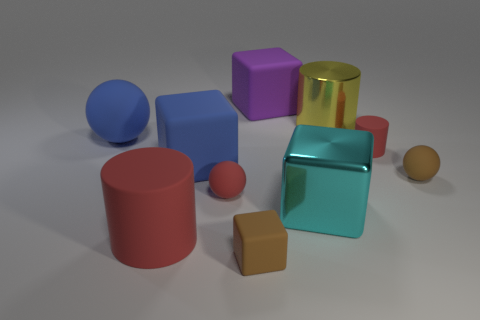What number of large blue rubber balls are left of the large cylinder on the left side of the small brown cube that is in front of the big metallic block?
Your answer should be compact. 1. Is the number of large blue matte cubes that are left of the large cyan object greater than the number of big cyan shiny blocks to the left of the yellow thing?
Provide a succinct answer. No. What number of things are either things on the left side of the tiny cylinder or cubes that are in front of the large yellow cylinder?
Keep it short and to the point. 8. What is the material of the block in front of the cylinder in front of the big blue rubber object in front of the large ball?
Give a very brief answer. Rubber. Does the tiny matte sphere that is to the right of the purple rubber cube have the same color as the large rubber cylinder?
Your answer should be compact. No. There is a thing that is on the left side of the blue cube and in front of the metallic cube; what is it made of?
Give a very brief answer. Rubber. Does the large red thing have the same material as the large sphere?
Keep it short and to the point. Yes. What number of large objects are behind the big cyan shiny object and right of the big purple block?
Provide a short and direct response. 1. How many other things are the same material as the purple cube?
Offer a terse response. 7. What is the size of the blue matte object that is the same shape as the purple object?
Your answer should be very brief. Large. 